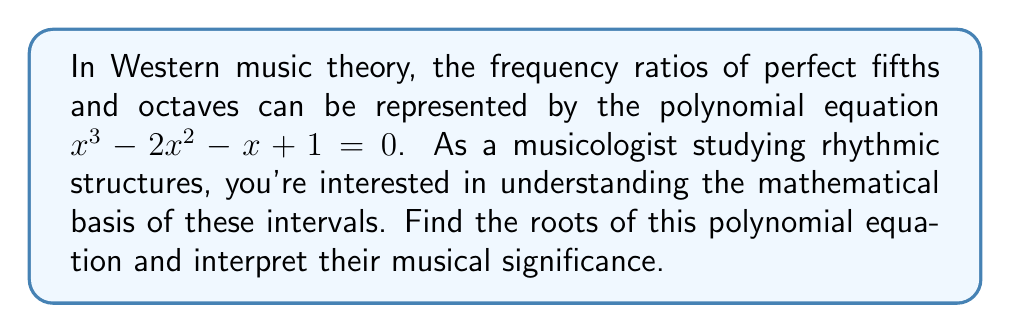Provide a solution to this math problem. To solve this polynomial equation, we'll use the following steps:

1) First, let's recognize that this is a cubic equation in the form $ax^3 + bx^2 + cx + d = 0$, where $a=1$, $b=-2$, $c=-1$, and $d=1$.

2) One method to solve this equation is to guess one root and then use polynomial long division to reduce it to a quadratic equation. In this case, we can observe that $x=1$ is a root because $1^3 - 2(1)^2 - 1 + 1 = 0$.

3) Using polynomial long division:

   $x^3 - 2x^2 - x + 1 = (x - 1)(x^2 - x - 1)$

4) Now we have reduced it to a quadratic equation: $x^2 - x - 1 = 0$

5) We can solve this using the quadratic formula: $x = \frac{-b \pm \sqrt{b^2 - 4ac}}{2a}$

   Where $a=1$, $b=-1$, and $c=-1$

6) Substituting these values:

   $x = \frac{1 \pm \sqrt{1 - 4(1)(-1)}}{2(1)} = \frac{1 \pm \sqrt{5}}{2}$

7) Therefore, the roots of the original equation are:

   $x_1 = 1$
   $x_2 = \frac{1 + \sqrt{5}}{2} \approx 1.618$
   $x_3 = \frac{1 - \sqrt{5}}{2} \approx -0.618$

Musical interpretation:
- The root $x_1 = 1$ represents unison (1:1 ratio).
- The root $x_2 \approx 1.618$ is close to the frequency ratio of a perfect fifth (3:2 ≈ 1.5).
- The root $x_3 \approx -0.618$ doesn't have a direct musical interpretation but its absolute value is the reciprocal of $x_2$, which could relate to the idea of interval inversion.

This polynomial encapsulates key frequency ratios in Western music theory, demonstrating the mathematical underpinnings of musical intervals.
Answer: The roots of the polynomial equation $x^3 - 2x^2 - x + 1 = 0$ are:

$x_1 = 1$
$x_2 = \frac{1 + \sqrt{5}}{2} \approx 1.618$
$x_3 = \frac{1 - \sqrt{5}}{2} \approx -0.618$ 